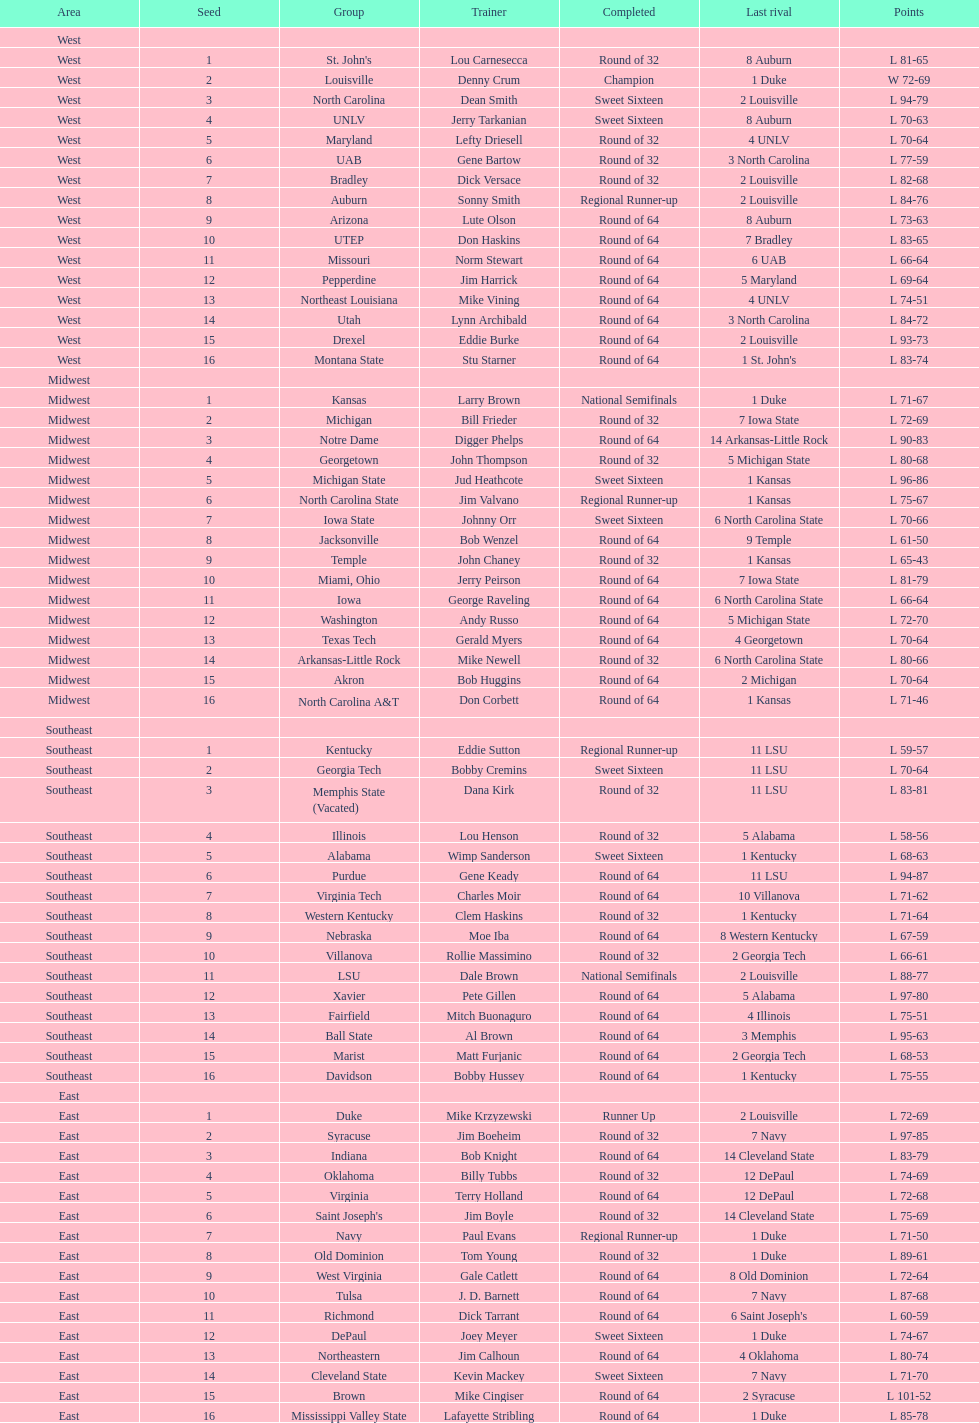Who is the only team from the east region to reach the final round? Duke. 